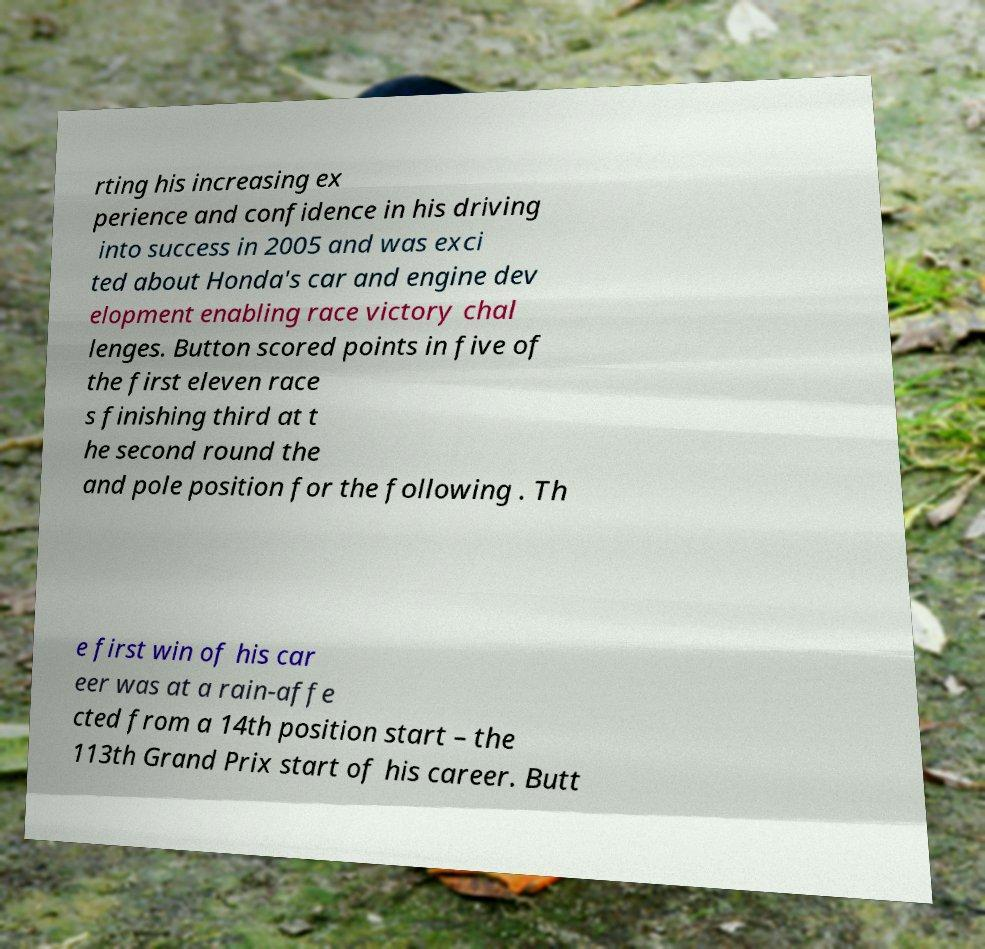Please read and relay the text visible in this image. What does it say? rting his increasing ex perience and confidence in his driving into success in 2005 and was exci ted about Honda's car and engine dev elopment enabling race victory chal lenges. Button scored points in five of the first eleven race s finishing third at t he second round the and pole position for the following . Th e first win of his car eer was at a rain-affe cted from a 14th position start – the 113th Grand Prix start of his career. Butt 